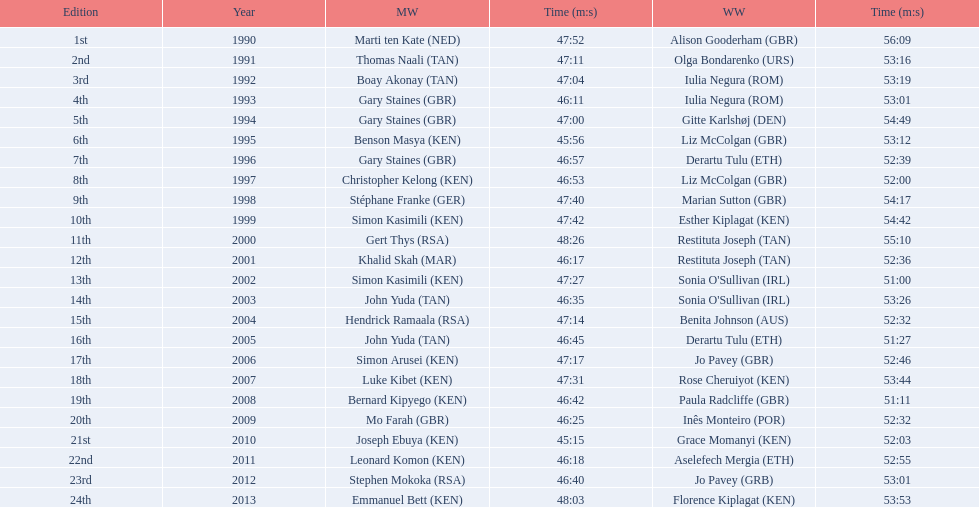Which runners are from kenya? (ken) Benson Masya (KEN), Christopher Kelong (KEN), Simon Kasimili (KEN), Simon Kasimili (KEN), Simon Arusei (KEN), Luke Kibet (KEN), Bernard Kipyego (KEN), Joseph Ebuya (KEN), Leonard Komon (KEN), Emmanuel Bett (KEN). Of these, which times are under 46 minutes? Benson Masya (KEN), Joseph Ebuya (KEN). Which of these runners had the faster time? Joseph Ebuya (KEN). 